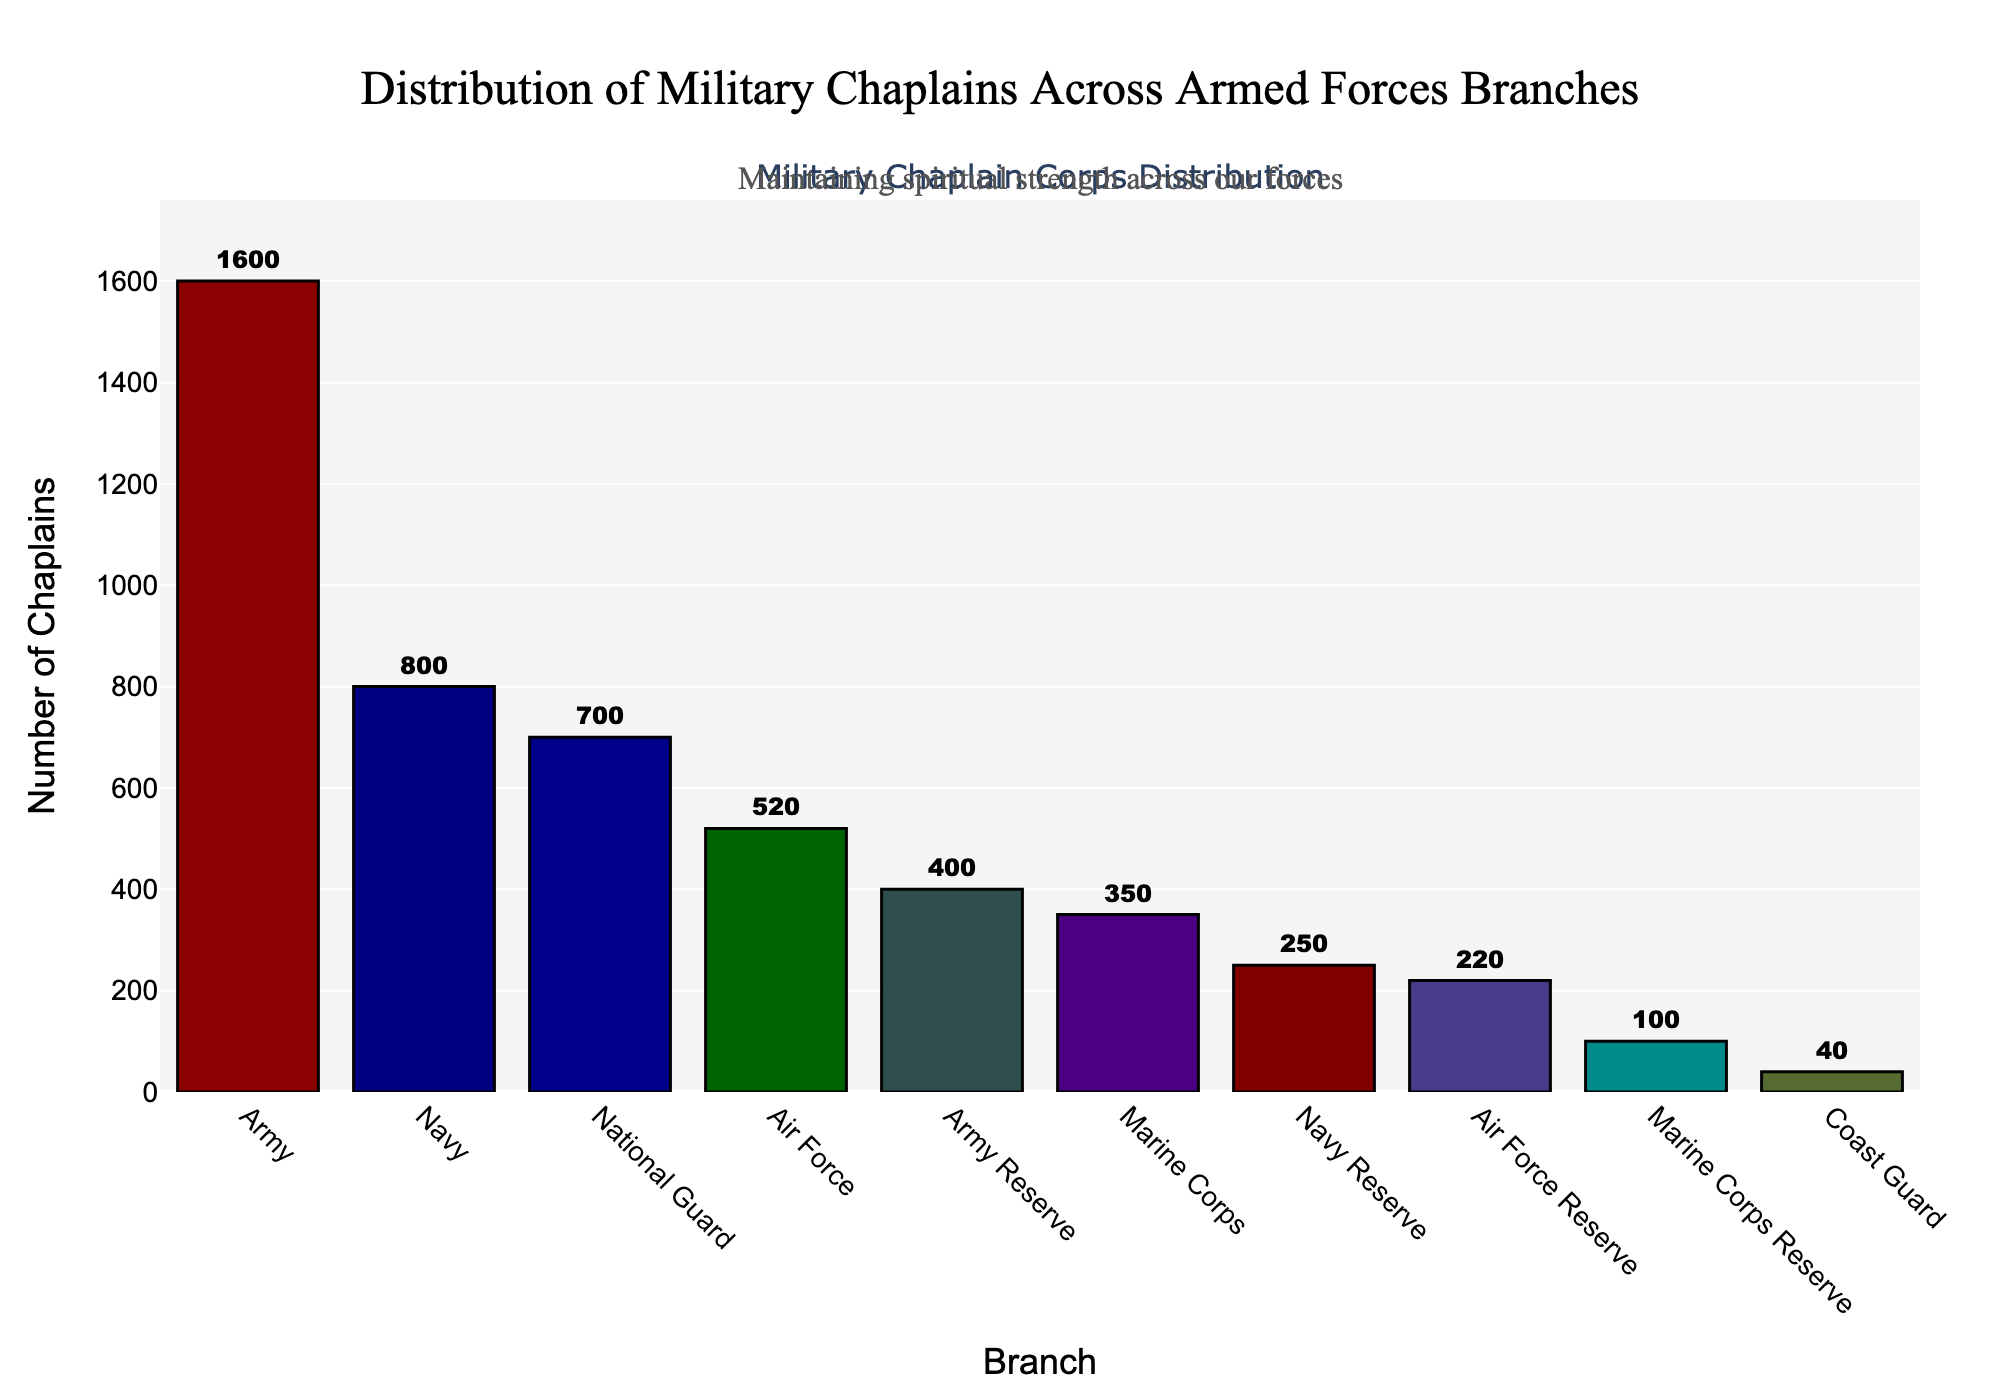What's the branch with the highest number of chaplains? By looking at the highest bar in the figure, the Army branch has the highest number of chaplains among all branches.
Answer: Army Which branch has more chaplains: the Army Reserve or the Marine Corps Reserve? By comparing the heights of the bars for the Army Reserve and the Marine Corps Reserve, the Army Reserve has a higher bar, indicating it has more chaplains.
Answer: Army Reserve What's the total number of chaplains in the Navy, Navy Reserve, and Marine Corps combined? By summing the number of chaplains in the Navy (800), Navy Reserve (250), and Marine Corps (350), the total is 800 + 250 + 350 = 1400.
Answer: 1400 Which reserve branch has the smallest number of chaplains, and how many? By examining the heights of the bars for reserve branches, the Marine Corps Reserve has the smallest number of chaplains with 100.
Answer: Marine Corps Reserve, 100 What's the average number of chaplains in the Army, Navy, and Air Force? The sum of the number of chaplains in the Army (1600), Navy (800), and Air Force (520) is 1600 + 800 + 520 = 2920. The average is 2920 / 3 = 973.33.
Answer: 973.33 How many more chaplains does the Army have compared to the Coast Guard? By subtracting the number of chaplains in the Coast Guard (40) from the number in the Army (1600), the difference is 1600 - 40 = 1560.
Answer: 1560 How many chaplains are there in total across all branches? By summing the number of chaplains in all branches: 1600 (Army) + 800 (Navy) + 520 (Air Force) + 350 (Marine Corps) + 40 (Coast Guard) + 700 (National Guard) + 400 (Army Reserve) + 250 (Navy Reserve) + 220 (Air Force Reserve) + 100 (Marine Corps Reserve), the total is 4980.
Answer: 4980 Which two branches have chaplain numbers closest to each other? By comparing the heights of the bars, the Air Force (520) and National Guard (700) have relatively close numbers, but closer are the Air Force Reserve (220) and Navy Reserve (250), with a difference of just 30.
Answer: Air Force Reserve & Navy Reserve What is the median number of chaplains among all branches? After sorting the numbers: 40 (Coast Guard), 100 (Marine Corps Reserve), 220 (Air Force Reserve), 250 (Navy Reserve), 350 (Marine Corps), 400 (Army Reserve), 520 (Air Force), 700 (National Guard), 800 (Navy), 1600 (Army). Median is the average of the 5th and 6th numbers: (350 + 400) / 2 = 375.
Answer: 375 